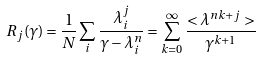<formula> <loc_0><loc_0><loc_500><loc_500>R _ { j } ( \gamma ) = \frac { 1 } { N } \sum _ { i } \frac { \lambda _ { i } ^ { j } } { \gamma - \lambda _ { i } ^ { n } } = \sum _ { k = 0 } ^ { \infty } \frac { < \lambda ^ { n k + j } > } { \gamma ^ { k + 1 } }</formula> 